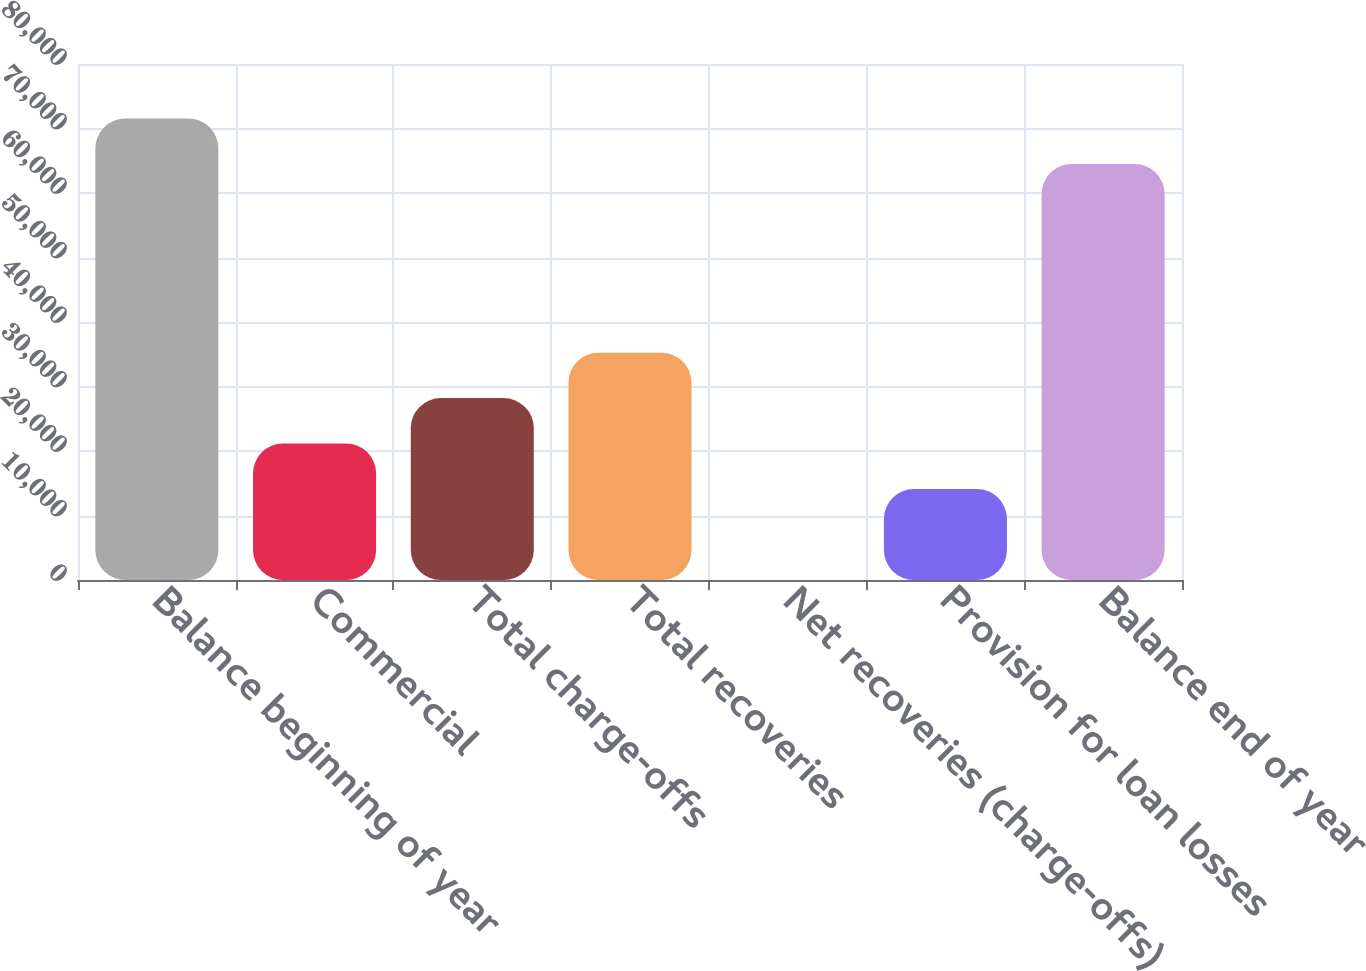Convert chart. <chart><loc_0><loc_0><loc_500><loc_500><bar_chart><fcel>Balance beginning of year<fcel>Commercial<fcel>Total charge-offs<fcel>Total recoveries<fcel>Net recoveries (charge-offs)<fcel>Provision for loan losses<fcel>Balance end of year<nl><fcel>71549.6<fcel>21152.7<fcel>28202.3<fcel>35251.9<fcel>3.88<fcel>14103.1<fcel>64500<nl></chart> 